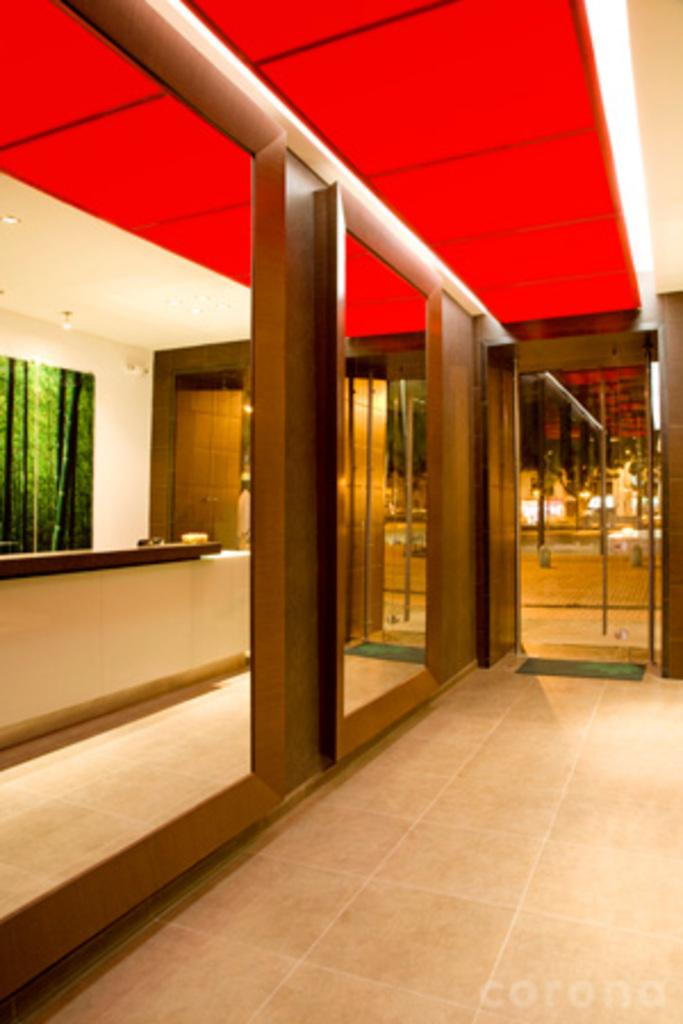What can be seen in the foreground of the image? The floor is visible in the foreground of the image. What furniture is located on the left side of the image? There is a desk on the left side of the image. What is hanging on the wall in the image? There is a frame on the wall in the image. What type of illumination is present in the image? Lights are present in the image. What is visible at the top of the image? The ceiling is visible in the image. What objects might be used for reflection in the image? There are mirrors in the image. How many boys are playing with cars in the image? There are no boys or cars present in the image. What type of curve can be seen in the image? There is no curve visible in the image. 